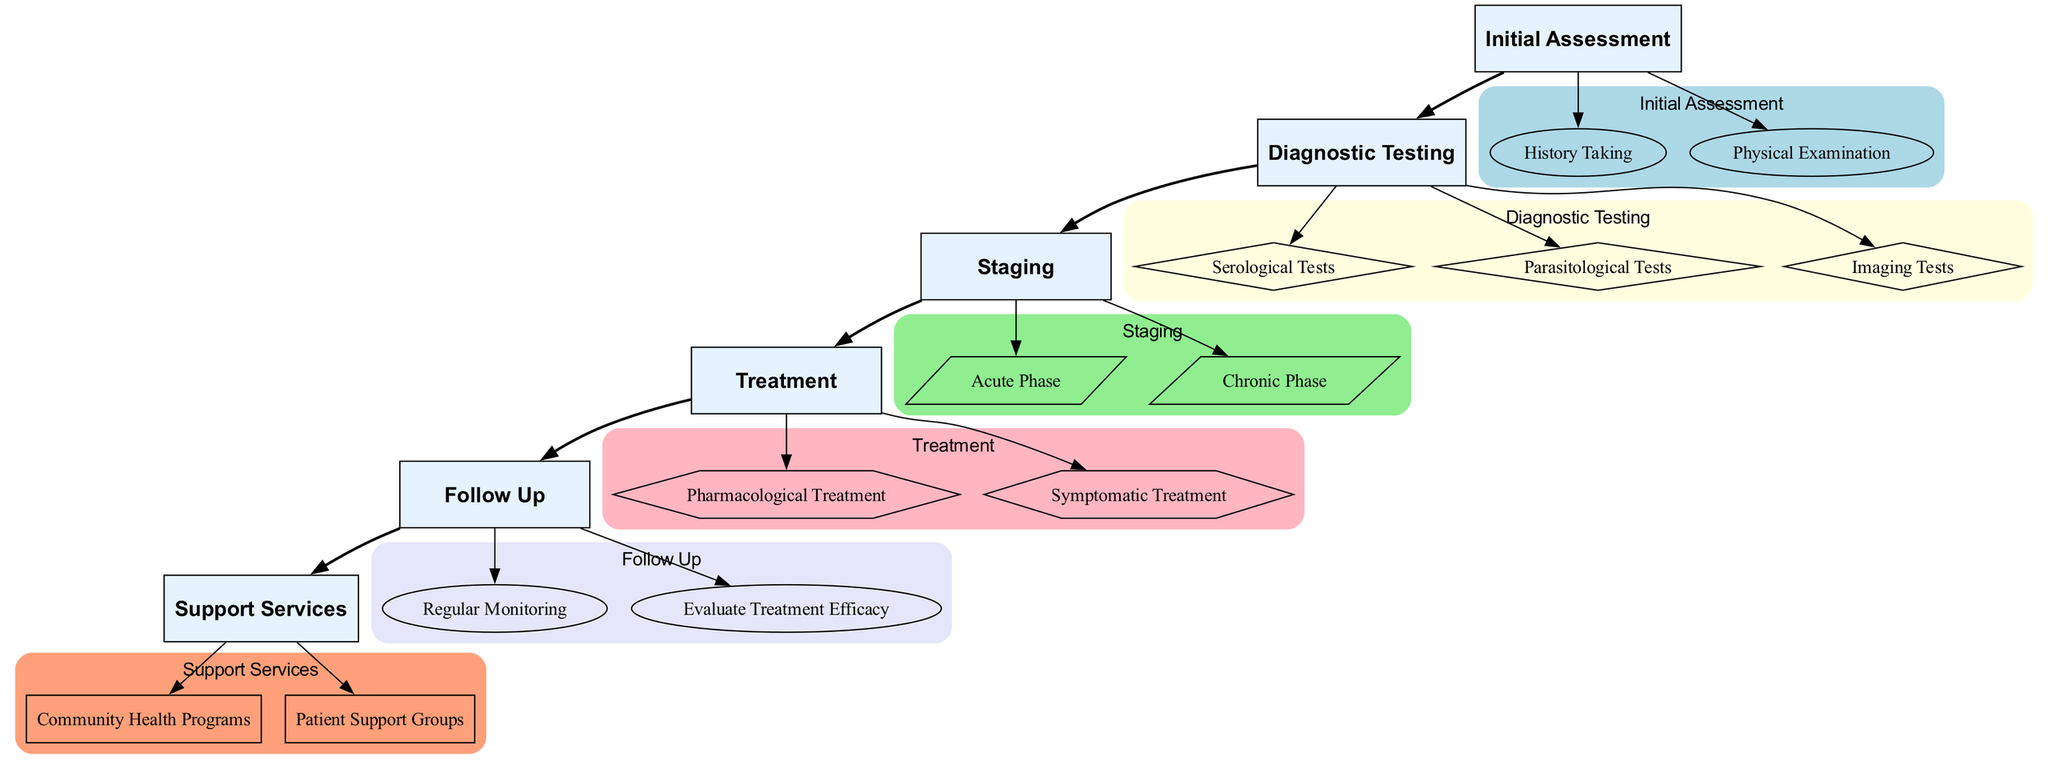What are the two main components of Initial Assessment? The diagram shows that the Initial Assessment consists of two components: History Taking and Physical Examination. These are the two sub-nodes directly connected to the Initial Assessment node.
Answer: History Taking, Physical Examination What is the first step in the Treatment phase? Within the Treatment phase, the first sub-node is Pharmacological Treatment, which is indicated as the first component connected to Treatment.
Answer: Pharmacological Treatment How many types of Diagnostic Testing are listed? The diagram outlines three distinct categories of Diagnostic Testing: Serological Tests, Parasitological Tests, and Imaging Tests. Thus, the total number is three.
Answer: 3 What are the criteria for evaluating treatment efficacy? The diagram lists three criteria for evaluating treatment efficacy: reduction in symptom severity, absence of detectable parasitic DNA, and stabilized or improved cardiac function. These criteria are highlighted in the Evaluate Treatment Efficacy node.
Answer: Reduction in symptom severity, absence of detectable parasitic DNA, stabilized or improved cardiac function In which phase would you find the presence of trypomastigotes in the blood? The diagram indicates that the presence of trypomastigotes in the blood is a characteristic of the Acute Phase, which is clearly stated under the Staging section.
Answer: Acute Phase What are the follow-up frequencies recommended? The Regular Monitoring section in the Follow Up phase specifies that monitoring should happen every 6 to 12 months. This information can be extracted directly from that node.
Answer: Every 6 to 12 months Which testing method is used for detecting cardiac involvement? The diagram specifies that an Electrocardiogram (ECG) is used for detecting cardiac involvement, which is directly stated under the Imaging Tests in the Diagnostic Testing section.
Answer: Electrocardiogram (ECG) What is one important consideration for Pharmacological Treatment? One consideration listed in the diagram for Pharmacological Treatment is the Age of patient, which is mentioned as a factor that affects treatment decisions.
Answer: Age of patient 